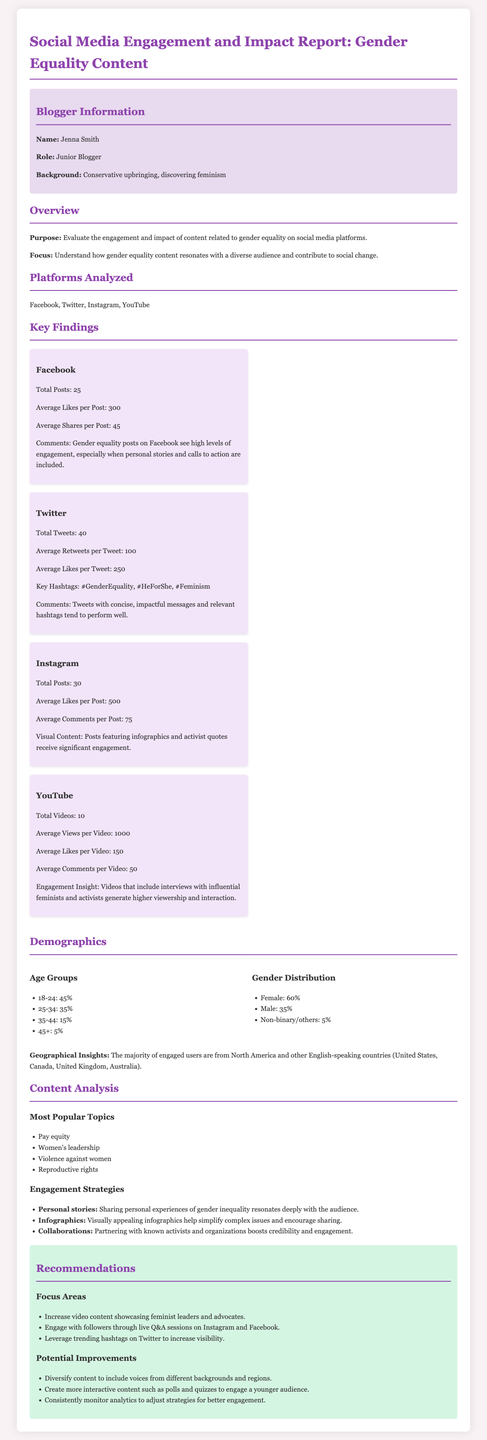what is the total number of Facebook posts? The total number of Facebook posts mentioned in the document is found under the platform analysis section specifically for Facebook.
Answer: 25 what is the average likes per Instagram post? The average likes per Instagram post is located in the Instagram platform analysis part of the document.
Answer: 500 which gender has the highest percentage in demographics? The demographics section indicates which gender has the highest proportion among engaged users.
Answer: Female what is the engagement strategy involving personal experiences? The document outlines engagement strategies and highlights one specific approach related to sharing personal experiences.
Answer: Personal stories what are the key hashtags mentioned for Twitter? The key hashtags for Twitter can be found in the Twitter platform analysis section.
Answer: #GenderEquality, #HeForShe, #Feminism how many total tweets were analyzed? The total number of tweets analyzed is stated in the Twitter platform analysis section.
Answer: 40 which geographical region has the majority of engaged users? The demographics section notes the geographical insights regarding engaged users.
Answer: North America what is the average number of views per YouTube video? The average number of views for YouTube videos is detailed in the YouTube platform analysis.
Answer: 1000 what is one of the most popular topics discussed in the content analysis? The most popular topics can be found in the content analysis section, highlighting various issues.
Answer: Pay equity 